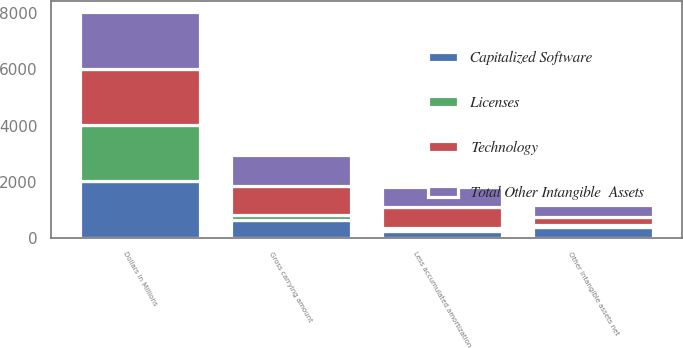Convert chart to OTSL. <chart><loc_0><loc_0><loc_500><loc_500><stacked_bar_chart><ecel><fcel>Dollars in Millions<fcel>Gross carrying amount<fcel>Less accumulated amortization<fcel>Other intangible assets net<nl><fcel>Licenses<fcel>2008<fcel>156<fcel>103<fcel>53<nl><fcel>Capitalized Software<fcel>2008<fcel>650<fcel>250<fcel>400<nl><fcel>Total Other Intangible  Assets<fcel>2008<fcel>1107<fcel>704<fcel>403<nl><fcel>Technology<fcel>2008<fcel>1040<fcel>745<fcel>295<nl></chart> 